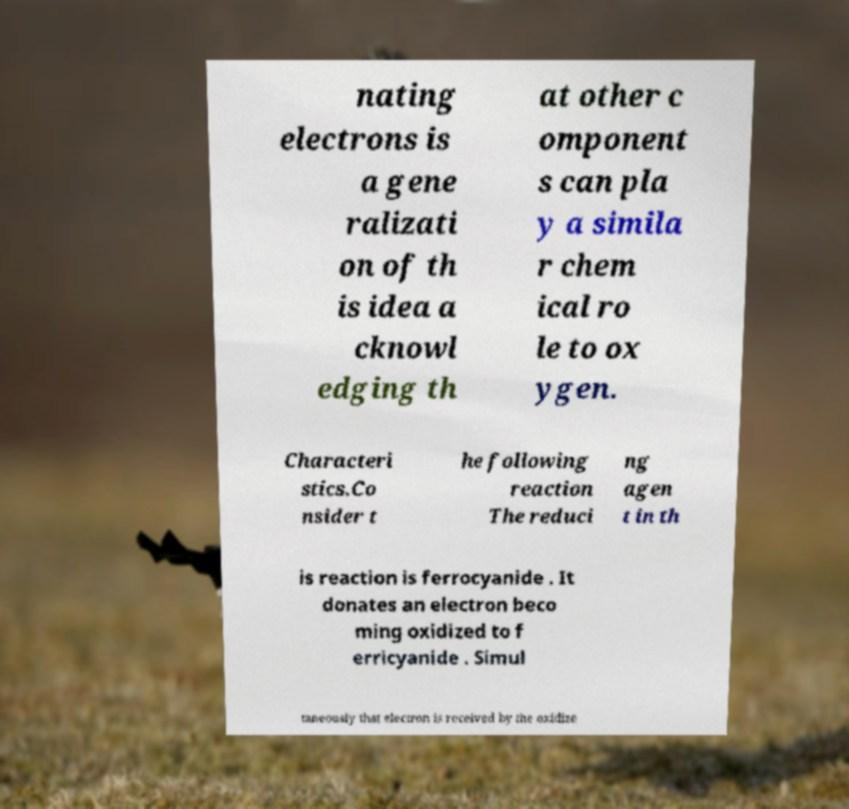Can you accurately transcribe the text from the provided image for me? nating electrons is a gene ralizati on of th is idea a cknowl edging th at other c omponent s can pla y a simila r chem ical ro le to ox ygen. Characteri stics.Co nsider t he following reaction The reduci ng agen t in th is reaction is ferrocyanide . It donates an electron beco ming oxidized to f erricyanide . Simul taneously that electron is received by the oxidize 